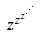Convert formula to latex. <formula><loc_0><loc_0><loc_500><loc_500>z ^ { z ^ { z ^ { \cdot ^ { \cdot ^ { \cdot } } } } }</formula> 